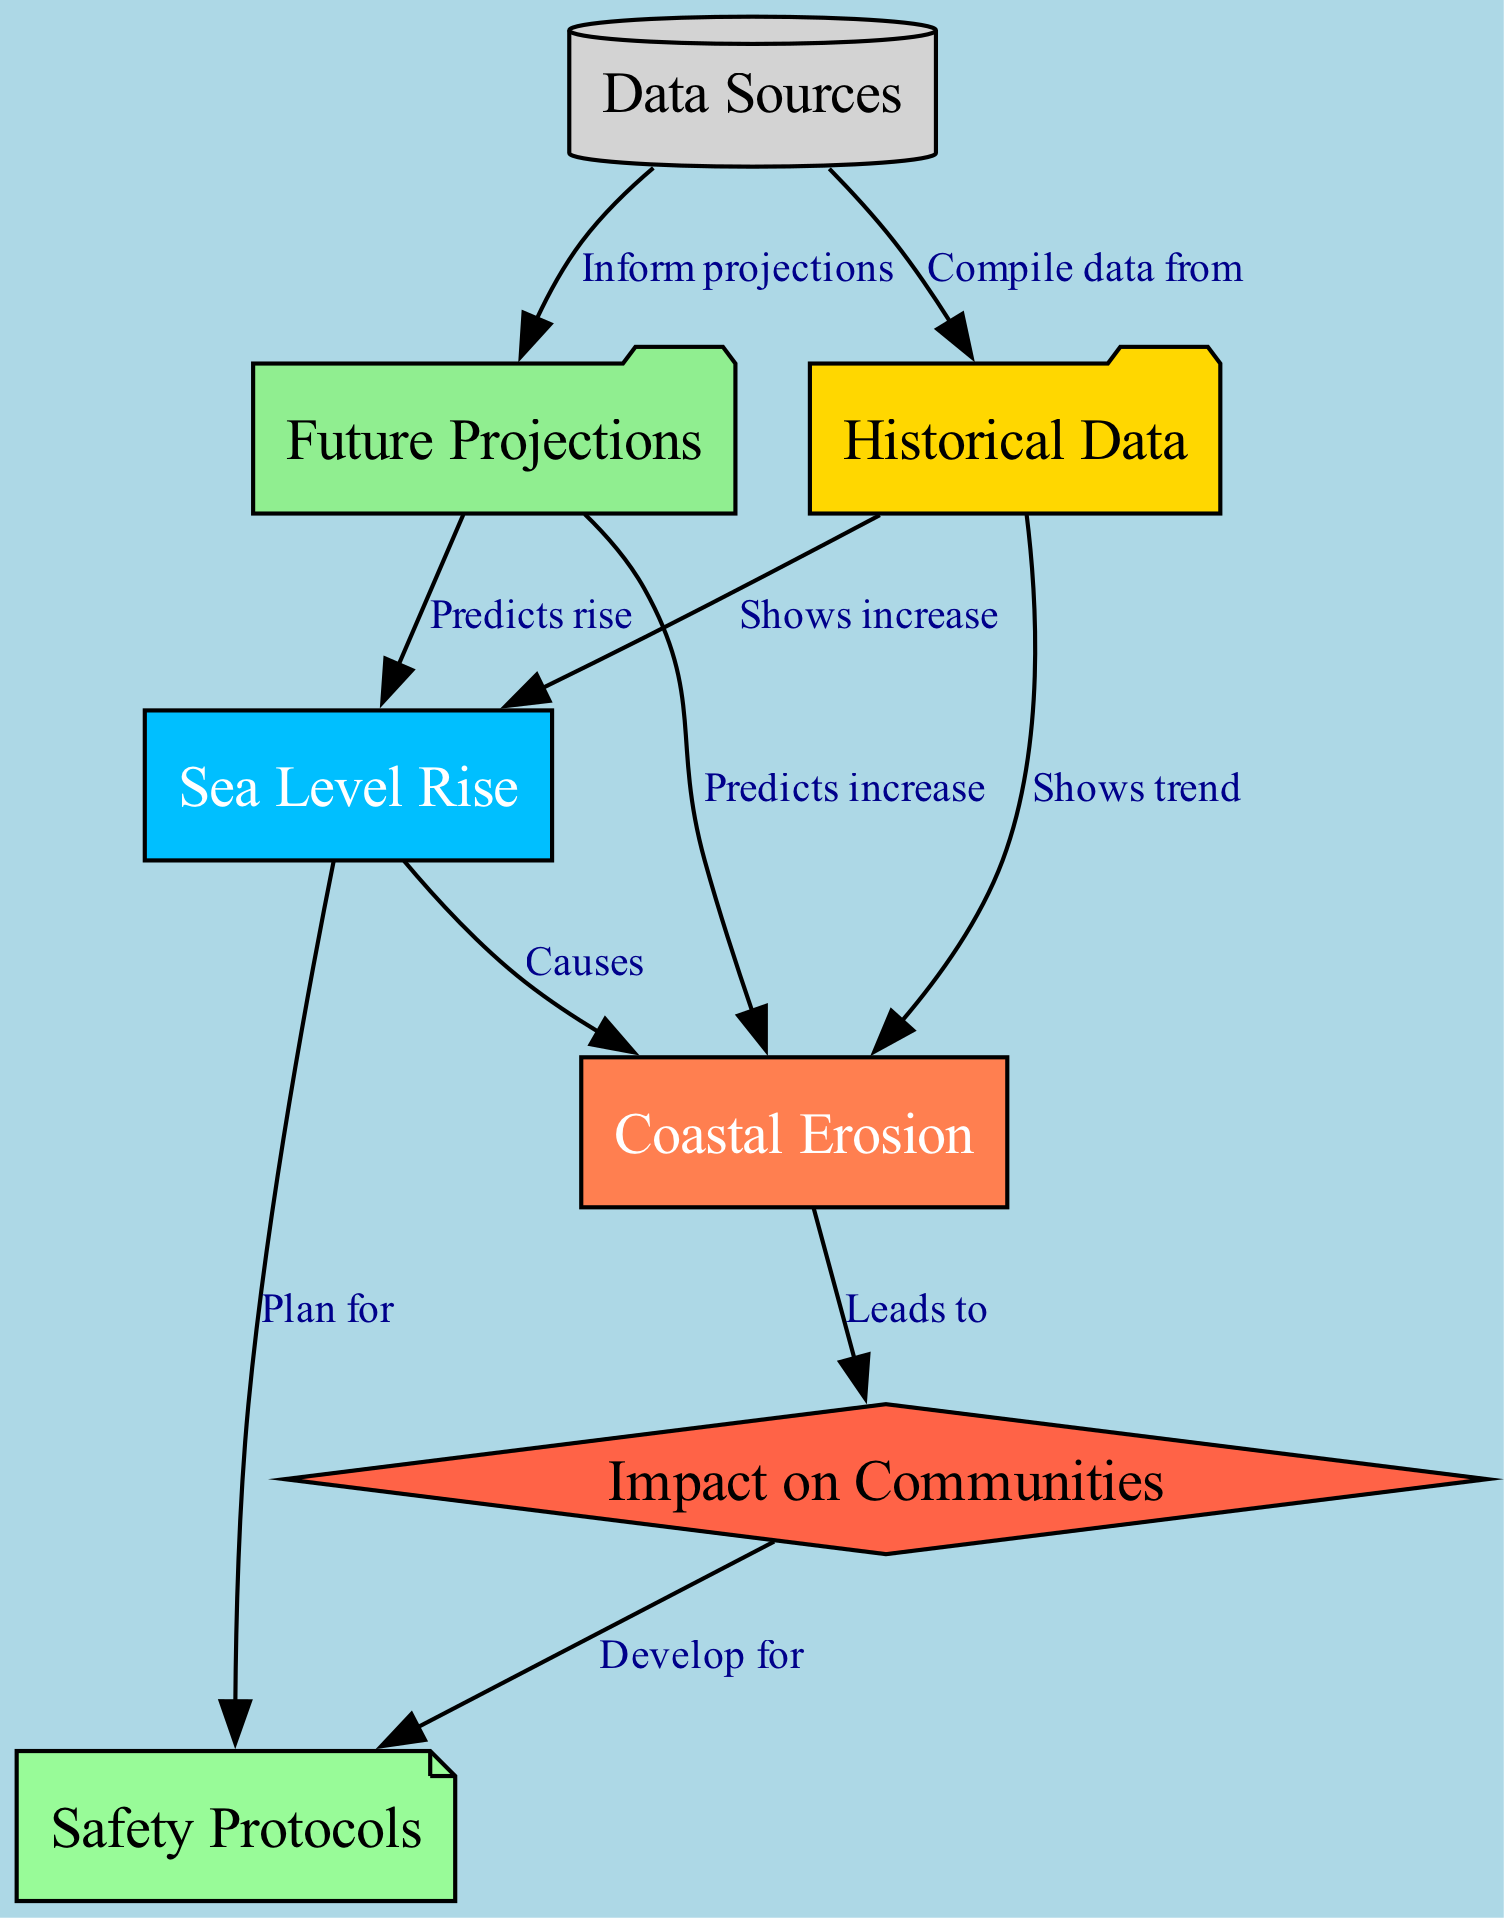What two elements does sea level rise cause? According to the diagram, sea level rise leads to coastal erosion. Therefore, the two elements related to sea level rise in the diagram would be coastal erosion and safety protocols.
Answer: Coastal erosion and safety protocols How many nodes are present in the diagram? By counting the distinct nodes shown in the diagram, we find there are seven different nodes: Coastal Erosion, Sea Level Rise, Historical Data, Future Projections, Data Sources, Impact on Communities, and Safety Protocols.
Answer: Seven What is the relationship between historical data and sea level rise? The diagram indicates that historical data shows an increase in sea level rise. This describes a clear relationship where historical data is used to illustrate the changes in sea level.
Answer: Shows increase What does future projections predict for coastal erosion? The diagram states that future projections predict an increase in coastal erosion. Future projections provide an outlook based on the information in the diagram, indicating expected trends.
Answer: Predicts increase What type of node is "Impact on Communities"? In the diagram, "Impact on Communities" is represented by a diamond-shaped node. This shape generally indicates a decision or result in the context of flow diagrams, which aligns with how it is depicted here.
Answer: Diamond How does data sources affect future projections? The diagram illustrates that data sources inform future projections by compiling data. Thus, data sources directly influence what is anticipated in future projections through the information they provide.
Answer: Inform projections What leads to the development of safety protocols? The impact on communities leads to the development of safety protocols. By analyzing the implications of coastal erosion and sea level rise on communities, safety measures can be established to mitigate risks.
Answer: Develop for What does historical data show about coastal erosion? The historical data in the diagram shows a trend related to coastal erosion. This means that it provides past information that helps understand how coastal erosion has changed over time.
Answer: Shows trend 